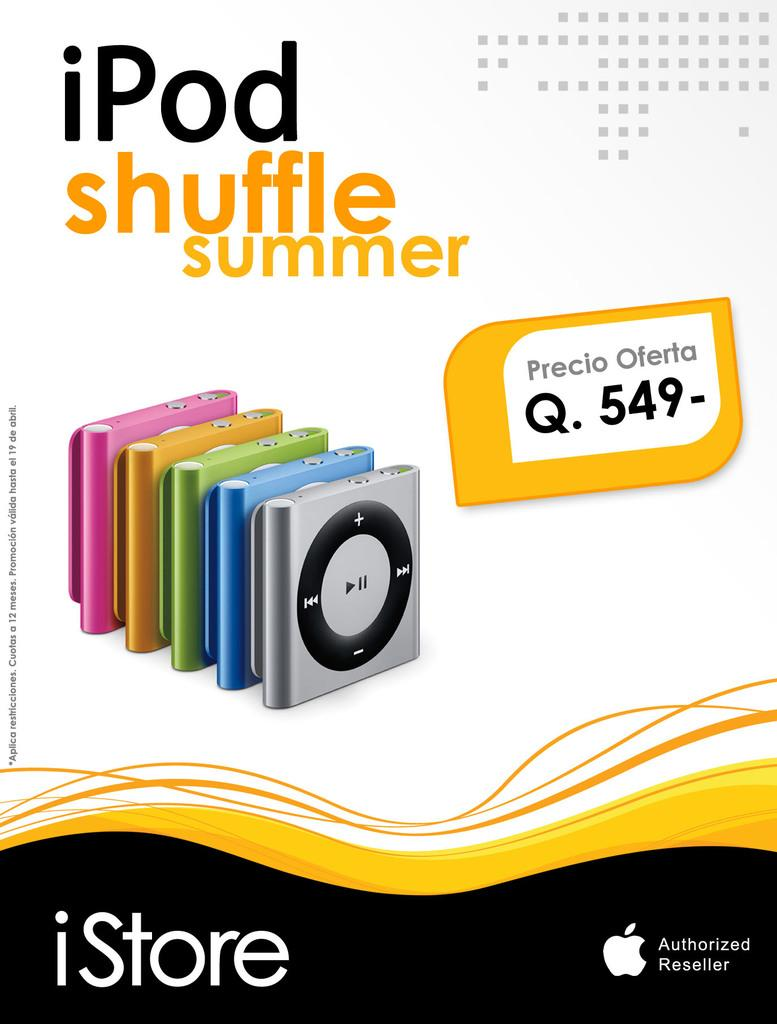What is featured on the poster in the image? There is a poster in the image that displays multiple iPads. Can you tell me the price of the iPads on the poster? Yes, the price of the iPads is visible on the poster. What else can be seen on the poster besides the iPads and their prices? There is text present on the poster. What type of rake is shown being used to stir the oatmeal in the image? There is no rake or oatmeal present in the image; it features a poster displaying multiple iPads with their prices and text. 